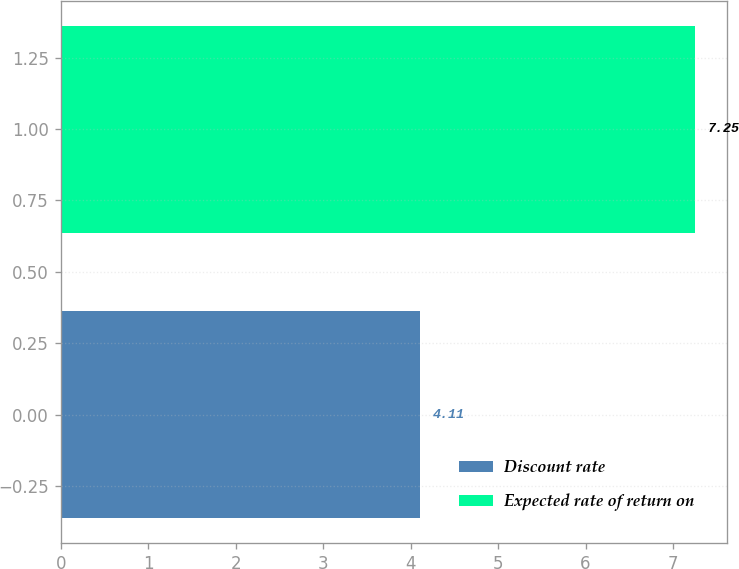Convert chart to OTSL. <chart><loc_0><loc_0><loc_500><loc_500><bar_chart><fcel>Discount rate<fcel>Expected rate of return on<nl><fcel>4.11<fcel>7.25<nl></chart> 